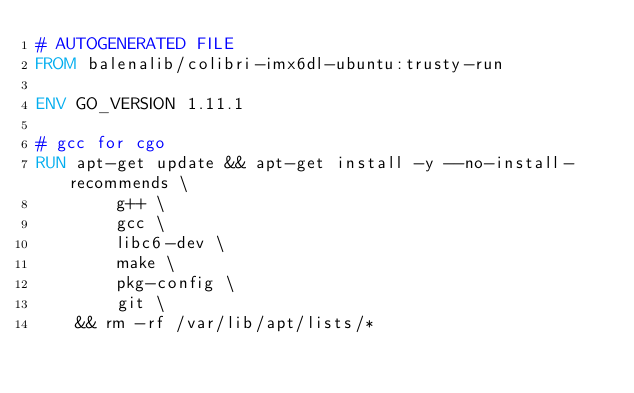<code> <loc_0><loc_0><loc_500><loc_500><_Dockerfile_># AUTOGENERATED FILE
FROM balenalib/colibri-imx6dl-ubuntu:trusty-run

ENV GO_VERSION 1.11.1

# gcc for cgo
RUN apt-get update && apt-get install -y --no-install-recommends \
		g++ \
		gcc \
		libc6-dev \
		make \
		pkg-config \
		git \
	&& rm -rf /var/lib/apt/lists/*
</code> 